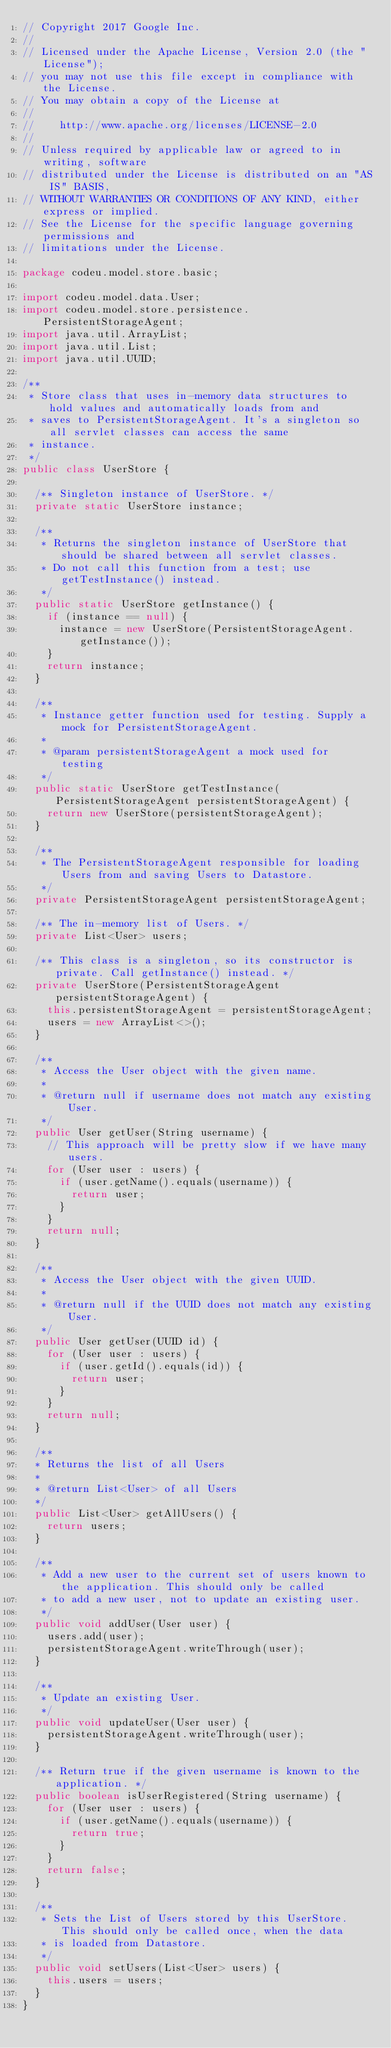<code> <loc_0><loc_0><loc_500><loc_500><_Java_>// Copyright 2017 Google Inc.
//
// Licensed under the Apache License, Version 2.0 (the "License");
// you may not use this file except in compliance with the License.
// You may obtain a copy of the License at
//
//    http://www.apache.org/licenses/LICENSE-2.0
//
// Unless required by applicable law or agreed to in writing, software
// distributed under the License is distributed on an "AS IS" BASIS,
// WITHOUT WARRANTIES OR CONDITIONS OF ANY KIND, either express or implied.
// See the License for the specific language governing permissions and
// limitations under the License.

package codeu.model.store.basic;

import codeu.model.data.User;
import codeu.model.store.persistence.PersistentStorageAgent;
import java.util.ArrayList;
import java.util.List;
import java.util.UUID;

/**
 * Store class that uses in-memory data structures to hold values and automatically loads from and
 * saves to PersistentStorageAgent. It's a singleton so all servlet classes can access the same
 * instance.
 */
public class UserStore {

  /** Singleton instance of UserStore. */
  private static UserStore instance;

  /**
   * Returns the singleton instance of UserStore that should be shared between all servlet classes.
   * Do not call this function from a test; use getTestInstance() instead.
   */
  public static UserStore getInstance() {
    if (instance == null) {
      instance = new UserStore(PersistentStorageAgent.getInstance());
    }
    return instance;
  }

  /**
   * Instance getter function used for testing. Supply a mock for PersistentStorageAgent.
   *
   * @param persistentStorageAgent a mock used for testing
   */
  public static UserStore getTestInstance(PersistentStorageAgent persistentStorageAgent) {
    return new UserStore(persistentStorageAgent);
  }

  /**
   * The PersistentStorageAgent responsible for loading Users from and saving Users to Datastore.
   */
  private PersistentStorageAgent persistentStorageAgent;

  /** The in-memory list of Users. */
  private List<User> users;

  /** This class is a singleton, so its constructor is private. Call getInstance() instead. */
  private UserStore(PersistentStorageAgent persistentStorageAgent) {
    this.persistentStorageAgent = persistentStorageAgent;
    users = new ArrayList<>();
  }

  /**
   * Access the User object with the given name.
   *
   * @return null if username does not match any existing User.
   */
  public User getUser(String username) {
    // This approach will be pretty slow if we have many users.
    for (User user : users) {
      if (user.getName().equals(username)) {
        return user;
      }
    }
    return null;
  }

  /**
   * Access the User object with the given UUID.
   *
   * @return null if the UUID does not match any existing User.
   */
  public User getUser(UUID id) {
    for (User user : users) {
      if (user.getId().equals(id)) {
        return user;
      }
    }
    return null;
  }

  /**
  * Returns the list of all Users
  *
  * @return List<User> of all Users
  */
  public List<User> getAllUsers() {
    return users;
  }

  /**
   * Add a new user to the current set of users known to the application. This should only be called
   * to add a new user, not to update an existing user.
   */
  public void addUser(User user) {
    users.add(user);
    persistentStorageAgent.writeThrough(user);
  }

  /**
   * Update an existing User.
   */
  public void updateUser(User user) {
    persistentStorageAgent.writeThrough(user);
  }

  /** Return true if the given username is known to the application. */
  public boolean isUserRegistered(String username) {
    for (User user : users) {
      if (user.getName().equals(username)) {
        return true;
      }
    }
    return false;
  }

  /**
   * Sets the List of Users stored by this UserStore. This should only be called once, when the data
   * is loaded from Datastore.
   */
  public void setUsers(List<User> users) {
    this.users = users;
  }
}
</code> 